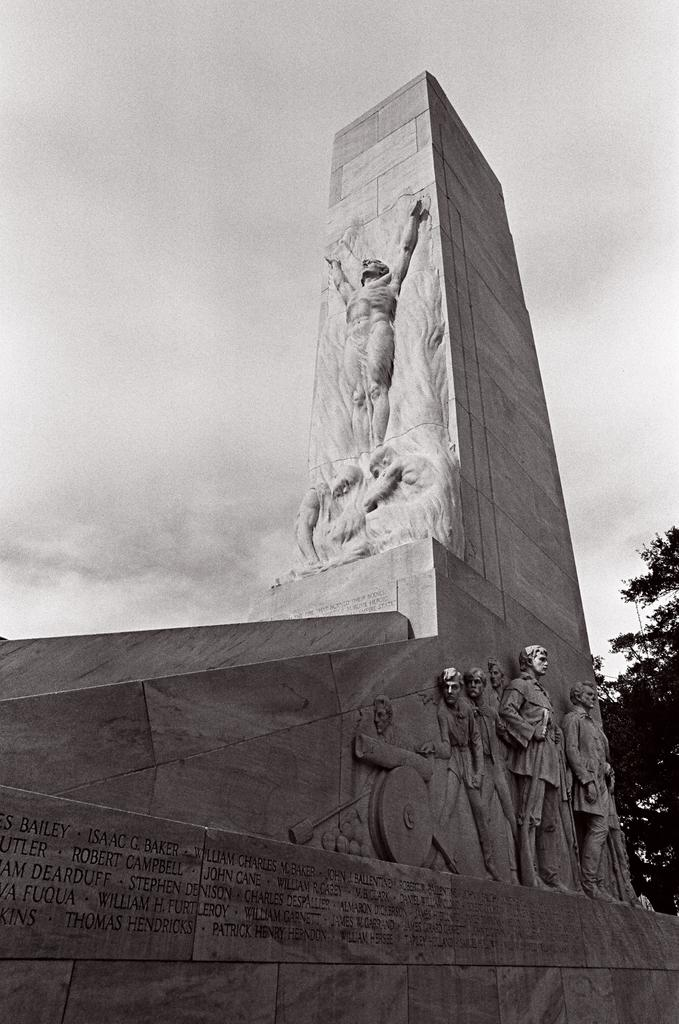What can be seen on the wall in the image? There are structures carved on a wall in the image. What is visible behind the wall in the image? There is a tree visible behind the wall in the image. How does the beggar angle their cup in the image? There is no beggar present in the image; it features a wall with carved structures and a tree behind it. 